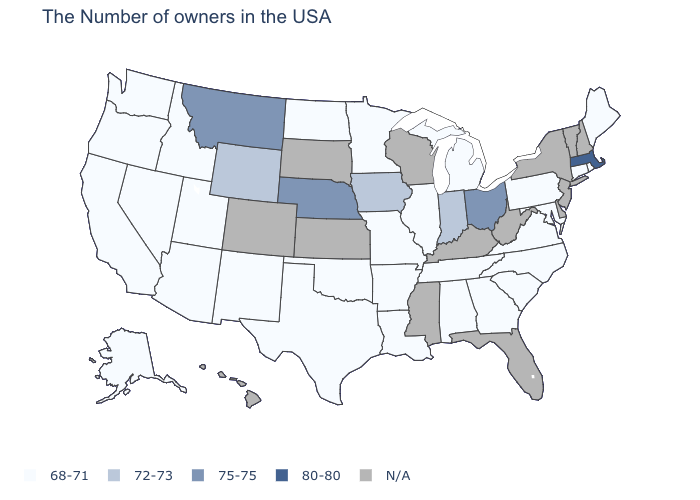What is the value of Colorado?
Be succinct. N/A. Name the states that have a value in the range 72-73?
Quick response, please. Indiana, Iowa, Wyoming. Does the map have missing data?
Be succinct. Yes. Which states have the lowest value in the USA?
Write a very short answer. Maine, Rhode Island, Connecticut, Maryland, Pennsylvania, Virginia, North Carolina, South Carolina, Georgia, Michigan, Alabama, Tennessee, Illinois, Louisiana, Missouri, Arkansas, Minnesota, Oklahoma, Texas, North Dakota, New Mexico, Utah, Arizona, Idaho, Nevada, California, Washington, Oregon, Alaska. What is the value of Wisconsin?
Be succinct. N/A. Does the map have missing data?
Give a very brief answer. Yes. What is the value of Iowa?
Answer briefly. 72-73. Which states have the lowest value in the South?
Concise answer only. Maryland, Virginia, North Carolina, South Carolina, Georgia, Alabama, Tennessee, Louisiana, Arkansas, Oklahoma, Texas. Among the states that border North Dakota , does Montana have the highest value?
Answer briefly. Yes. Does the first symbol in the legend represent the smallest category?
Concise answer only. Yes. What is the value of North Dakota?
Short answer required. 68-71. What is the value of New Hampshire?
Answer briefly. N/A. Does Utah have the highest value in the USA?
Keep it brief. No. Does Massachusetts have the highest value in the USA?
Concise answer only. Yes. What is the highest value in states that border North Dakota?
Quick response, please. 75-75. 